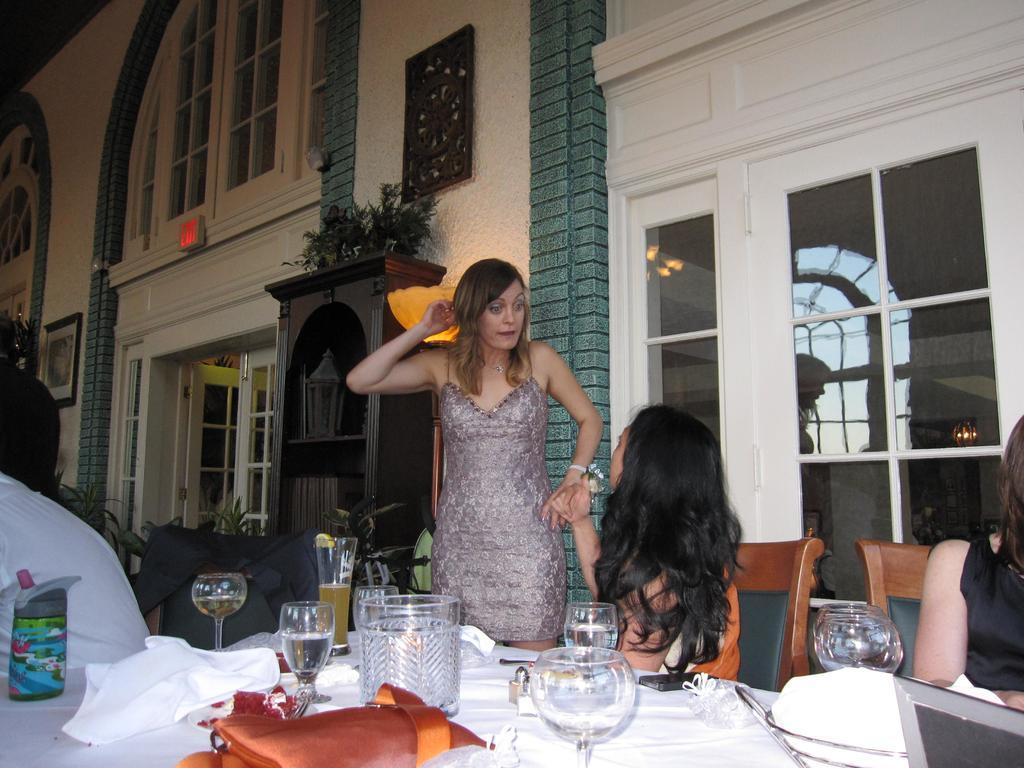Describe this image in one or two sentences. This is a image of a woman standing and another woman sitting in the chair , another woman sitting in the chair and in the table there is glass jar , some glasses, 1 pouch , tissues,napkins and at the back ground there is a big building with a door, window , plant in the cupboard and a wooden frame attached to the building and an exit board. 